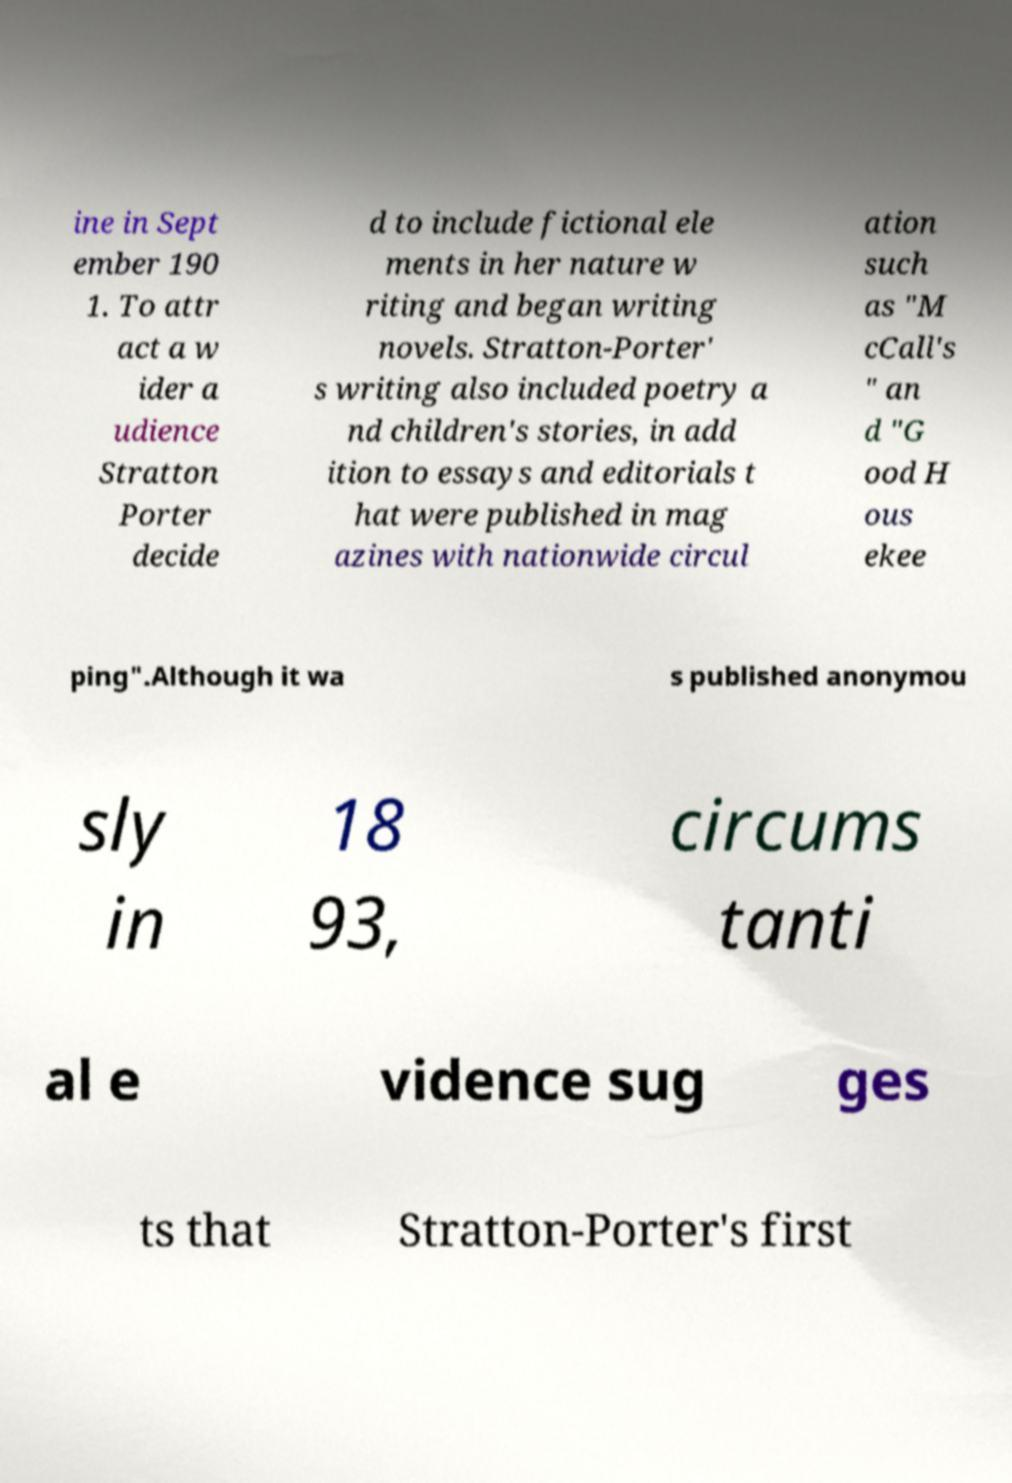Could you extract and type out the text from this image? ine in Sept ember 190 1. To attr act a w ider a udience Stratton Porter decide d to include fictional ele ments in her nature w riting and began writing novels. Stratton-Porter' s writing also included poetry a nd children's stories, in add ition to essays and editorials t hat were published in mag azines with nationwide circul ation such as "M cCall's " an d "G ood H ous ekee ping".Although it wa s published anonymou sly in 18 93, circums tanti al e vidence sug ges ts that Stratton-Porter's first 